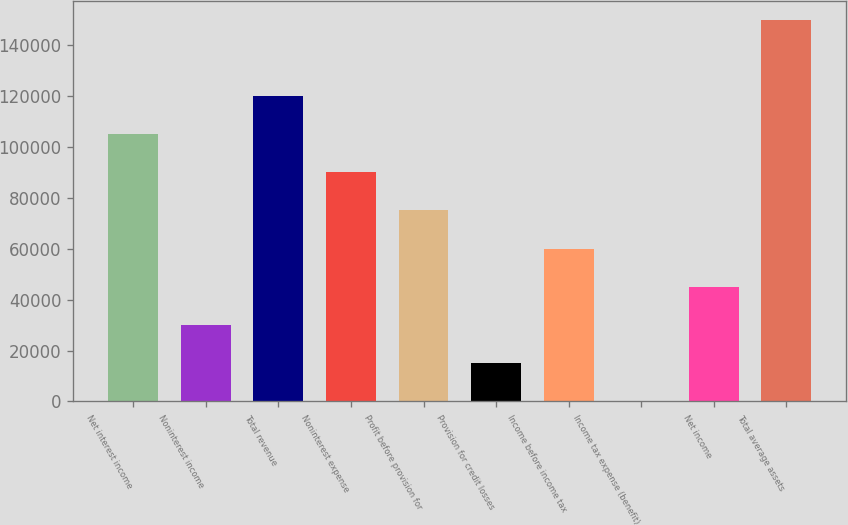Convert chart to OTSL. <chart><loc_0><loc_0><loc_500><loc_500><bar_chart><fcel>Net interest income<fcel>Noninterest income<fcel>Total revenue<fcel>Noninterest expense<fcel>Profit before provision for<fcel>Provision for credit losses<fcel>Income before income tax<fcel>Income tax expense (benefit)<fcel>Net income<fcel>Total average assets<nl><fcel>105045<fcel>30198.6<fcel>120014<fcel>90075.8<fcel>75106.5<fcel>15229.3<fcel>60137.2<fcel>260<fcel>45167.9<fcel>149953<nl></chart> 